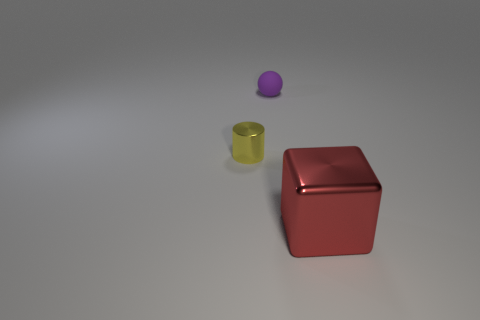Add 1 tiny brown matte cubes. How many objects exist? 4 Subtract all cubes. How many objects are left? 2 Subtract 0 brown spheres. How many objects are left? 3 Subtract all tiny purple rubber cylinders. Subtract all small yellow shiny things. How many objects are left? 2 Add 1 large red things. How many large red things are left? 2 Add 3 blue cylinders. How many blue cylinders exist? 3 